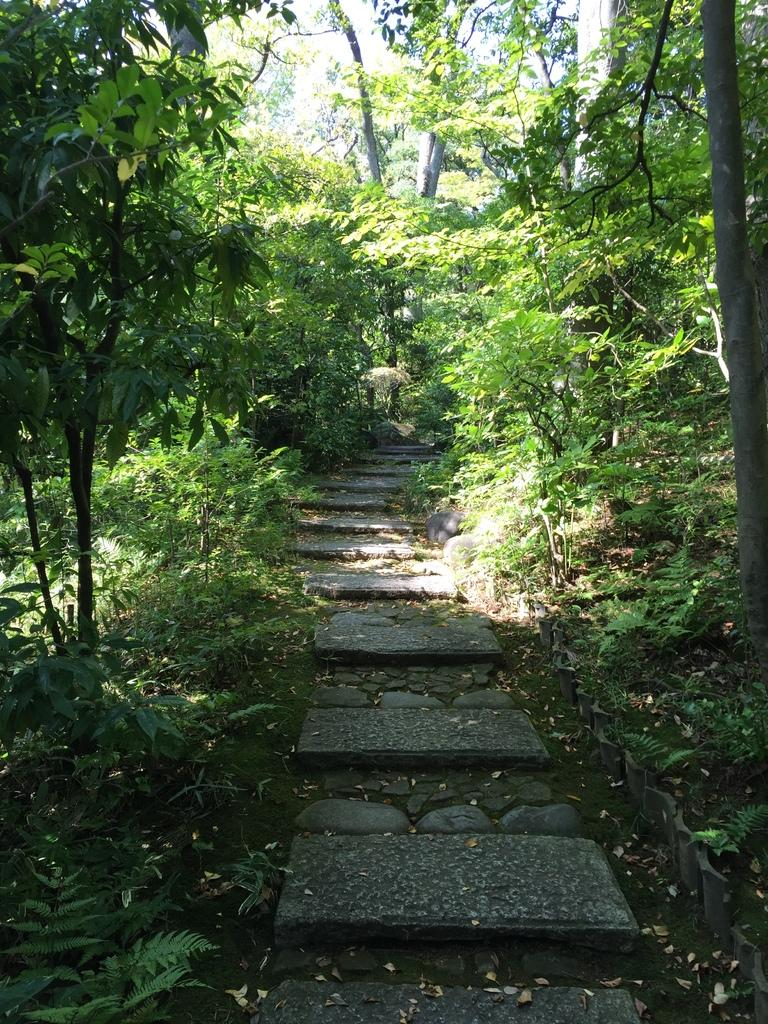What is the main feature in the center of the image? There is a walking area in the center of the image. What type of vegetation can be seen in the image? There are many plants and trees in the image. What type of cattle can be seen grazing in the image? There is no cattle present in the image; it features a walking area and vegetation. 